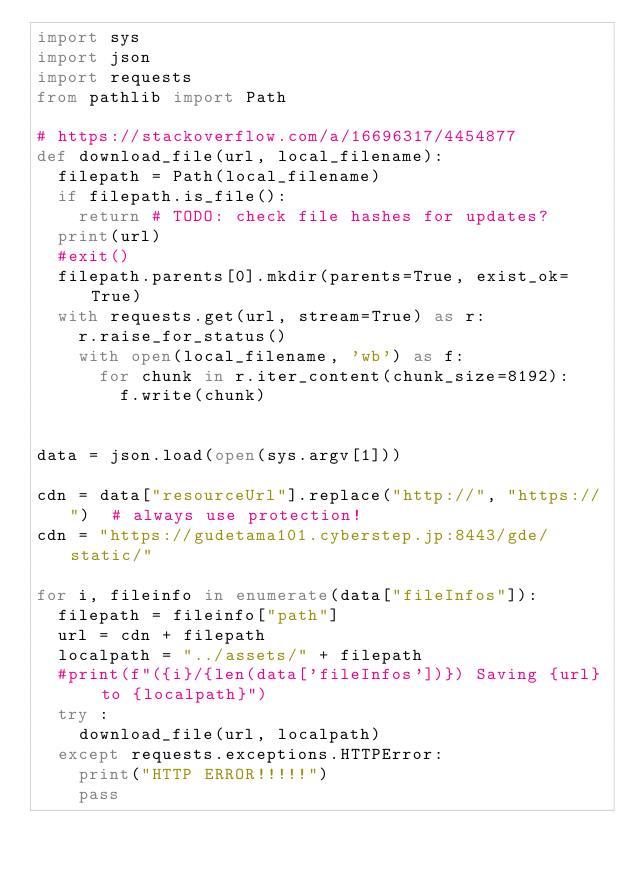Convert code to text. <code><loc_0><loc_0><loc_500><loc_500><_Python_>import sys
import json
import requests
from pathlib import Path

# https://stackoverflow.com/a/16696317/4454877
def download_file(url, local_filename):
	filepath = Path(local_filename)
	if filepath.is_file():
		return # TODO: check file hashes for updates?
	print(url)
	#exit()
	filepath.parents[0].mkdir(parents=True, exist_ok=True)
	with requests.get(url, stream=True) as r:
		r.raise_for_status()
		with open(local_filename, 'wb') as f:
			for chunk in r.iter_content(chunk_size=8192): 
				f.write(chunk)


data = json.load(open(sys.argv[1]))

cdn = data["resourceUrl"].replace("http://", "https://")  # always use protection!
cdn = "https://gudetama101.cyberstep.jp:8443/gde/static/"

for i, fileinfo in enumerate(data["fileInfos"]):
	filepath = fileinfo["path"]
	url = cdn + filepath
	localpath = "../assets/" + filepath
	#print(f"({i}/{len(data['fileInfos'])}) Saving {url} to {localpath}")
	try :
		download_file(url, localpath)
	except requests.exceptions.HTTPError:
		print("HTTP ERROR!!!!!")
		pass
</code> 